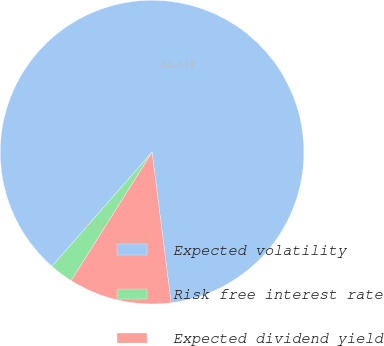Convert chart to OTSL. <chart><loc_0><loc_0><loc_500><loc_500><pie_chart><fcel>Expected volatility<fcel>Risk free interest rate<fcel>Expected dividend yield<nl><fcel>86.54%<fcel>2.52%<fcel>10.94%<nl></chart> 